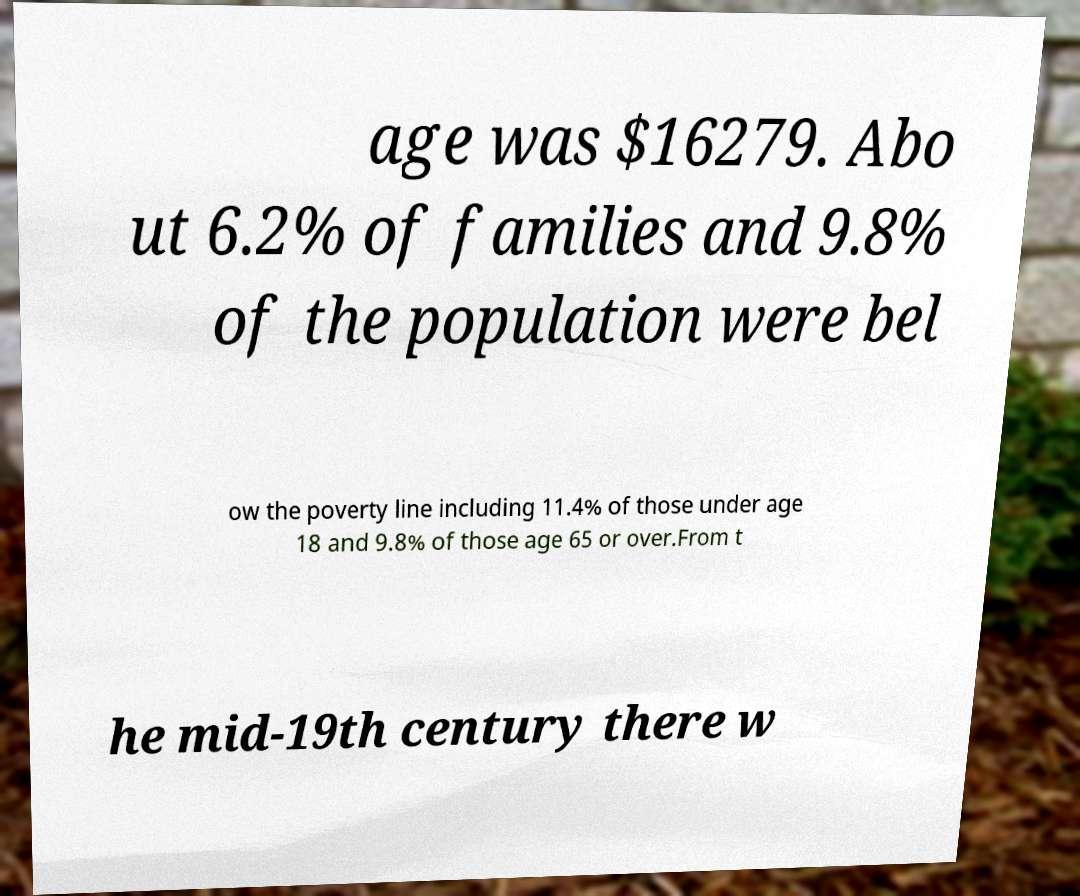Could you extract and type out the text from this image? age was $16279. Abo ut 6.2% of families and 9.8% of the population were bel ow the poverty line including 11.4% of those under age 18 and 9.8% of those age 65 or over.From t he mid-19th century there w 